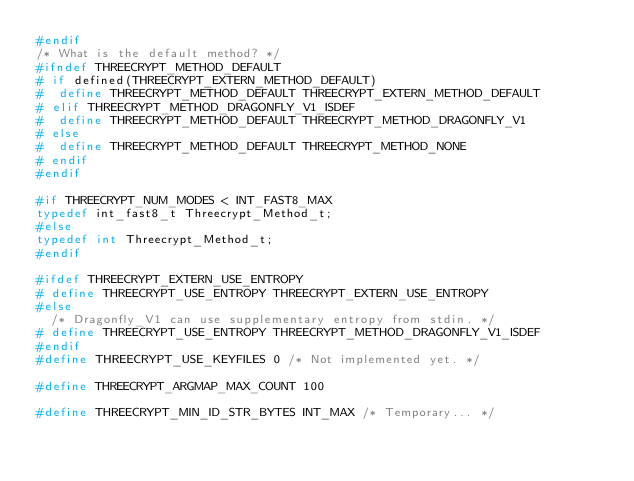<code> <loc_0><loc_0><loc_500><loc_500><_C_>#endif
/* What is the default method? */
#ifndef THREECRYPT_METHOD_DEFAULT
# if defined(THREECRYPT_EXTERN_METHOD_DEFAULT)
#  define THREECRYPT_METHOD_DEFAULT THREECRYPT_EXTERN_METHOD_DEFAULT
# elif THREECRYPT_METHOD_DRAGONFLY_V1_ISDEF
#  define THREECRYPT_METHOD_DEFAULT THREECRYPT_METHOD_DRAGONFLY_V1
# else
#  define THREECRYPT_METHOD_DEFAULT THREECRYPT_METHOD_NONE
# endif
#endif

#if THREECRYPT_NUM_MODES < INT_FAST8_MAX
typedef int_fast8_t Threecrypt_Method_t;
#else
typedef int Threecrypt_Method_t;
#endif

#ifdef THREECRYPT_EXTERN_USE_ENTROPY
# define THREECRYPT_USE_ENTROPY THREECRYPT_EXTERN_USE_ENTROPY
#else
  /* Dragonfly_V1 can use supplementary entropy from stdin. */
# define THREECRYPT_USE_ENTROPY THREECRYPT_METHOD_DRAGONFLY_V1_ISDEF
#endif
#define THREECRYPT_USE_KEYFILES 0 /* Not implemented yet. */

#define THREECRYPT_ARGMAP_MAX_COUNT	100

#define THREECRYPT_MIN_ID_STR_BYTES INT_MAX /* Temporary... */</code> 